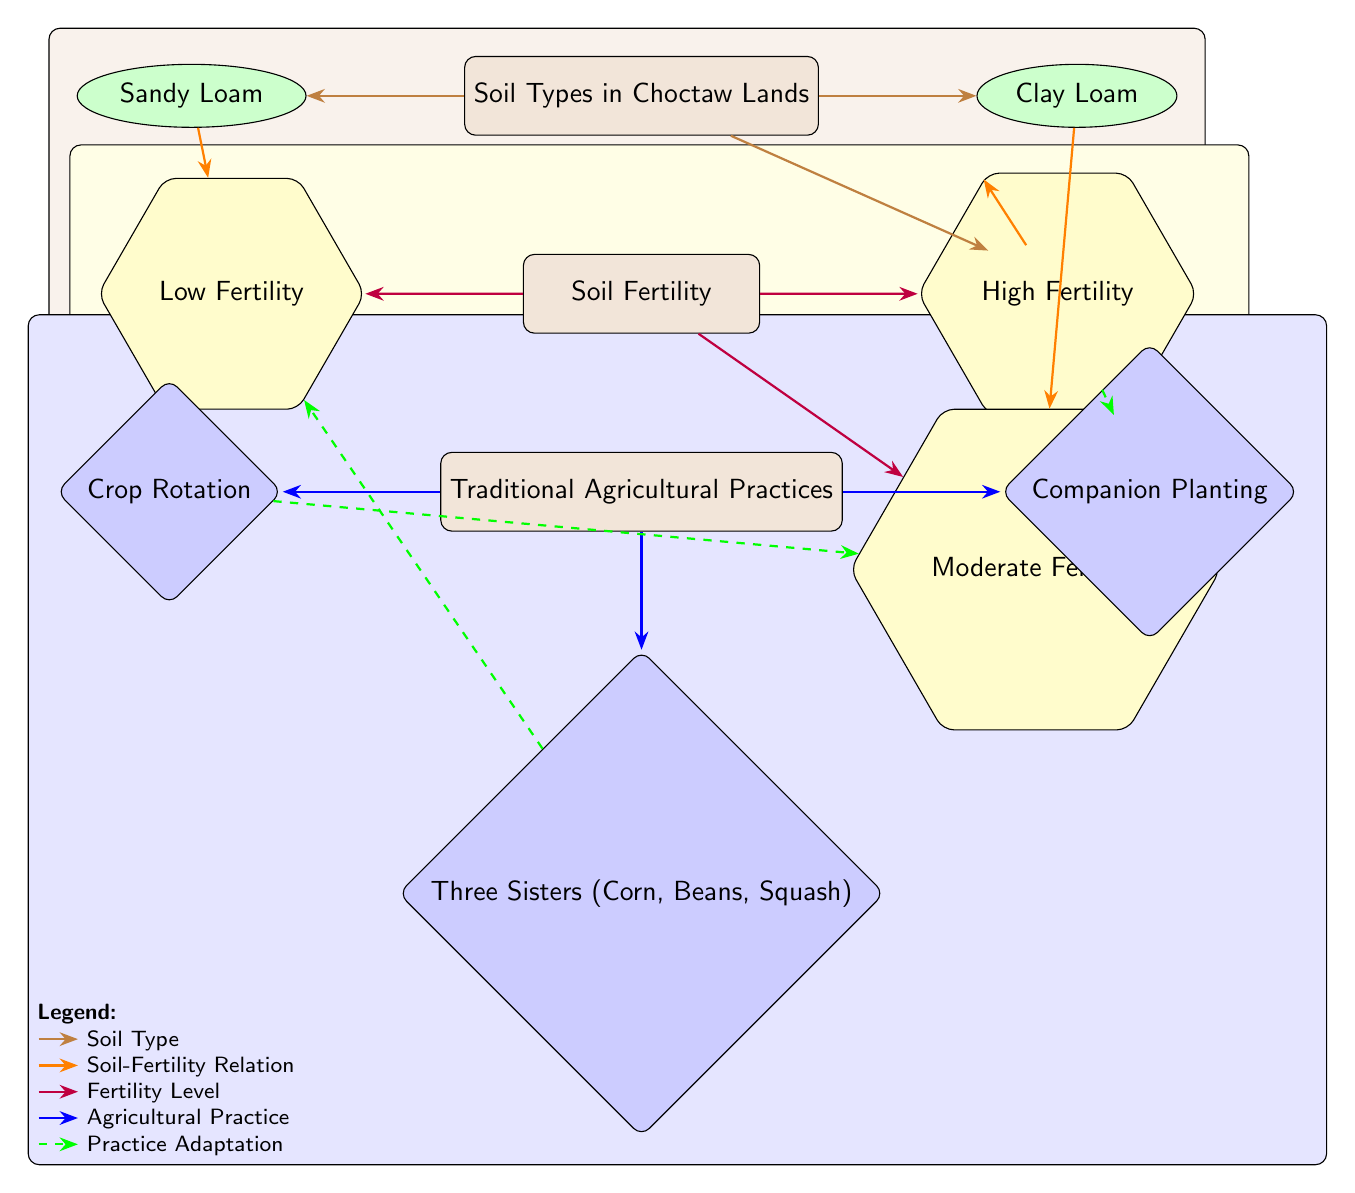What are the three soil types represented in the diagram? The diagram explicitly lists the three soil types in Choctaw lands as the main nodes connected to "Soil Types in Choctaw Lands". They are Sandy Loam, Clay Loam, and Silt Loam.
Answer: Sandy Loam, Clay Loam, Silt Loam Which soil type is associated with low fertility? The diagram shows a directed edge from Sandy Loam to Low Fertility, indicating that Sandy Loam is categorized under low fertility.
Answer: Sandy Loam What is the relationship between Clay Loam and moderate fertility? The diagram connects Clay Loam directly to Moderate Fertility through an edge, establishing a clear relationship that indicates Clay Loam is associated with moderate fertility.
Answer: Moderate Fertility How many agricultural practices are listed in the diagram? There are three agricultural practices shown as diamond nodes under the "Traditional Agricultural Practices" main node, which are Crop Rotation, Companion Planting, and Three Sisters.
Answer: Three Which agricultural practice is most associated with high fertility? Following the arrows in the diagram, Companion Planting has a direct edge to High Fertility, making it the agricultural practice most connected with this fertility level.
Answer: Companion Planting What type of relationship does "crop rotation" have with soil fertility? By examining the flow of the diagram, crop rotation has a dashed edge leading to moderate fertility, suggesting that it is adapted to this specific fertility level.
Answer: Moderate Fertility Which soil type has the highest fertility according to the diagram? The diagram clearly shows that Silt Loam is connected to High Fertility with a directed edge, identifying it as the soil type with the highest fertility.
Answer: High Fertility Which practice adapts to low fertility according to the diagram? The flow of the diagram indicates that the Three Sisters practice has a dashed edge leading to Low Fertility, signifying its adaptation to this fertility level.
Answer: Three Sisters What color represents the soil types in the diagram? The nodes representing soil types are filled with brown color, as indicated in the node style definitions within the diagram's code.
Answer: Brown 